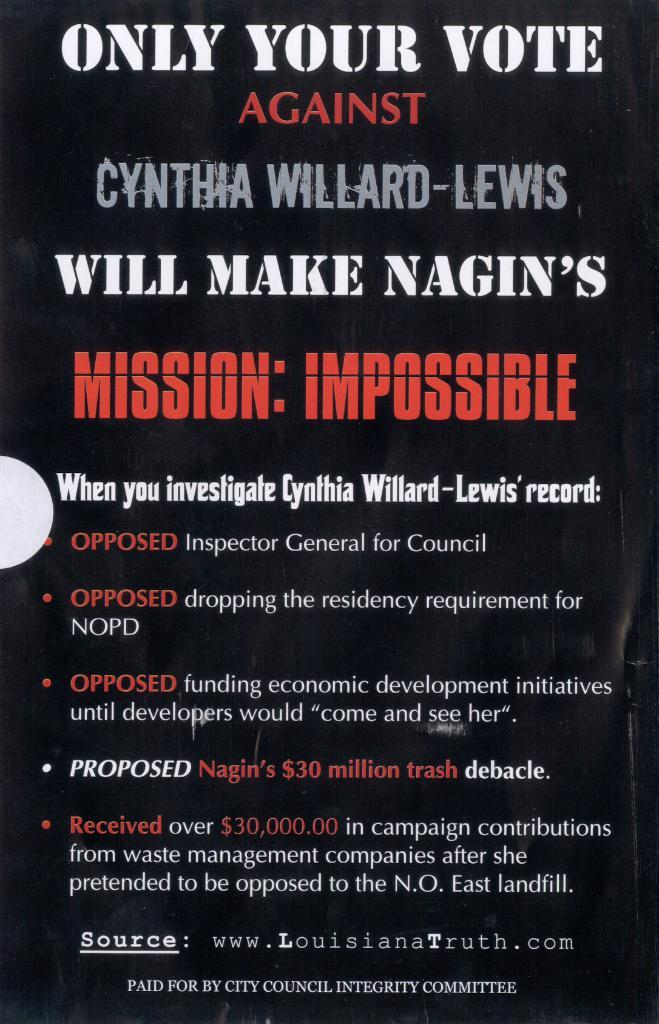<image>
Relay a brief, clear account of the picture shown. and ad that reads your vote against make nagins 